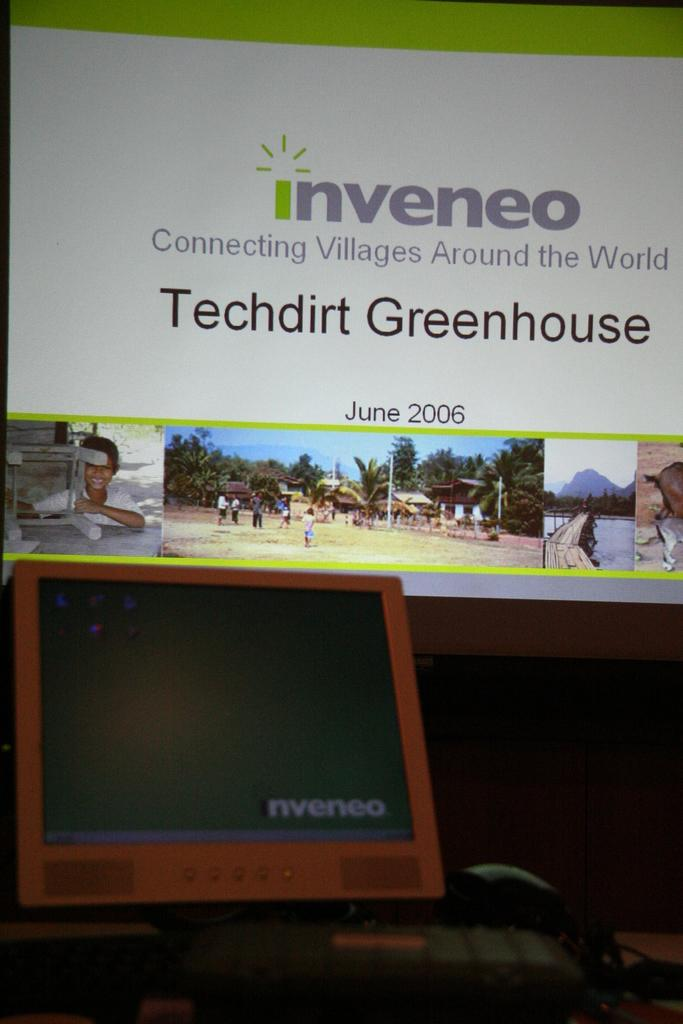<image>
Write a terse but informative summary of the picture. The app shown help to connect villages around the world. 